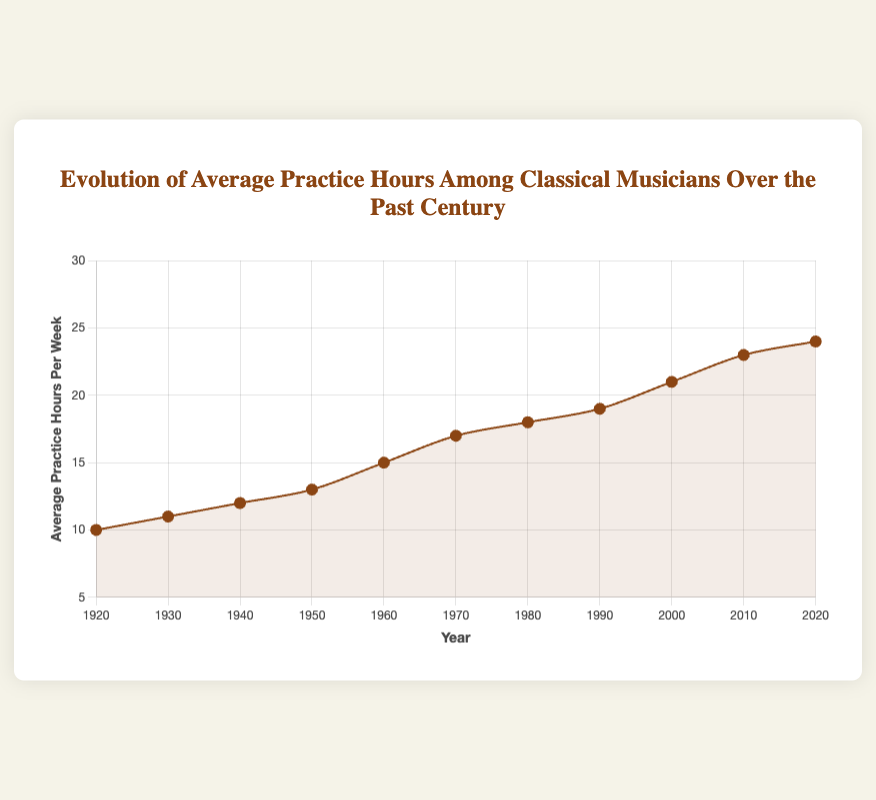What's the average practice hours per week in the first half of the century (1920-1960)? To find the average, sum the practice hours for 1920, 1930, 1940, 1950, and 1960, which are 10, 11, 12, 13, and 15, respectively, and then divide by the number of years: (10 + 11 + 12 + 13 + 15) / 5 = 61 / 5 = 12.2
Answer: 12.2 Which decade shows the largest increase in average practice hours per week? Calculate the difference in practice hours from one decade to the next and find the largest increase: 1920s-1930s (11-10=1), 1930s-1940s (12-11=1), 1940s-1950s (13-12=1), 1950s-1960s (15-13=2), 1960s-1970s (17-15=2), 1970s-1980s (18-17=1), 1980s-1990s (19-18=1), 1990s-2000s (21-19=2), 2000s-2010s (23-21=2), 2010s-2020s (24-23=1). The largest increase is between the 1950s and 1960s, 1960s and 1970s, 1990s and 2000s, and 2000s and 2010s with increases of 2 hours.
Answer: 1950s-1960s, 1960s-1970s, 1990s-2000s, 2000s-2010s What is the overall trend in the practice hours from 1920 to 2020? By looking at the data points, each decade sees an increase in practice hours from 10 in 1920 to 24 in 2020. Thus, the overall trend is an upward increase in practice hours over the century.
Answer: Increasing How many years did it take for the average practice hours to double from the 1920 level? The average practice hours in 1920 were 10. To find when it doubled, look for the year with 20 hours: checking each decade, in 2000, the hours reach 21 which is more than double. Therefore, it took from 1920 to 2000, which is 80 years.
Answer: 80 years Between which consecutive decades was the growth in average practice hours per week the slowest? Determine the smallest increase between consecutive decades: 1920s-1930s (11-10=1), 1930s-1940s (12-11=1), 1940s-1950s (13-12=1), 1950s-1960s (15-13=2), 1960s-1970s (17-15=2), 1970s-1980s (18-17=1), 1980s-1990s (19-18=1), 1990s-2000s (21-19=2), 2000s-2010s (23-21=2), 2010s-2020s (24-23=1). The smallest increases are 1 hour and occurred between 1920s-1930s, 1930s-1940s, 1940s-1950s, 1970s-1980s, and 1980s-1990s, 2010s-2020s.
Answer: 1920s-1930s, 1930s-1940s, 1940s-1950s, 1970s-1980s, 1980s-1990s, 2010s-2020s By how much did the practice hours increase from the midway point (1960s) to the end of the century (1990s)? Calculate the difference between practice hours in 1960 (15 hours) and 1990 (19 hours): 19 - 15 = 4 hours
Answer: 4 hours 